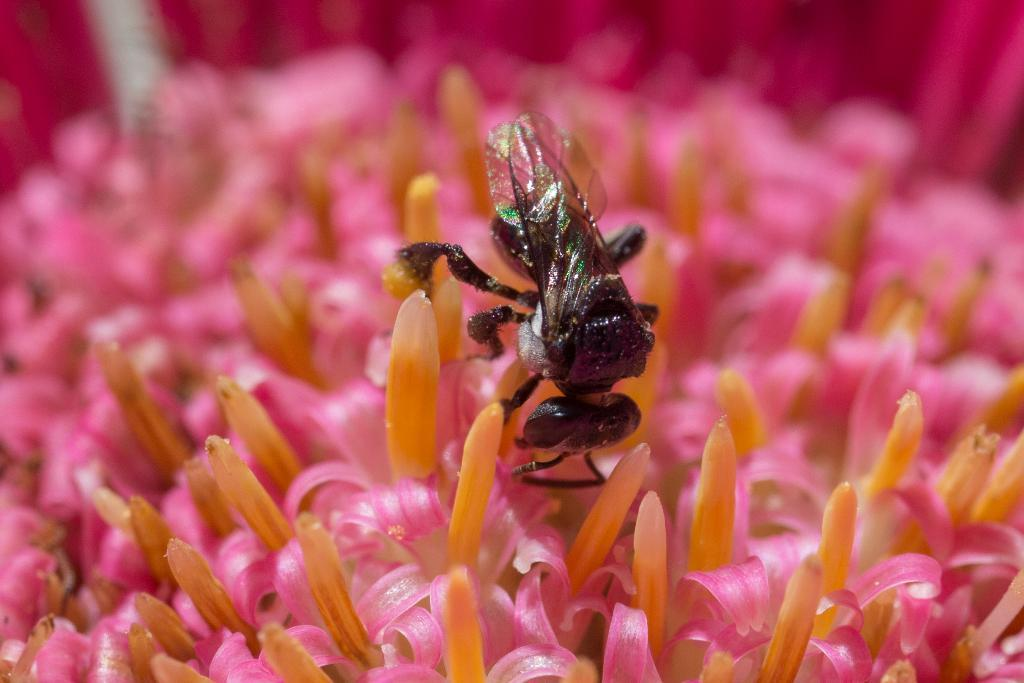What type of living organisms can be seen in the image? There are flowers in the image. What colors are the flowers? The flowers are in pink and orange colors. Is there any other living organism present in the image besides the flowers? Yes, there is a black color insect on the flowers. Can you see a monkey holding a knife in the image? No, there is no monkey or knife present in the image. 